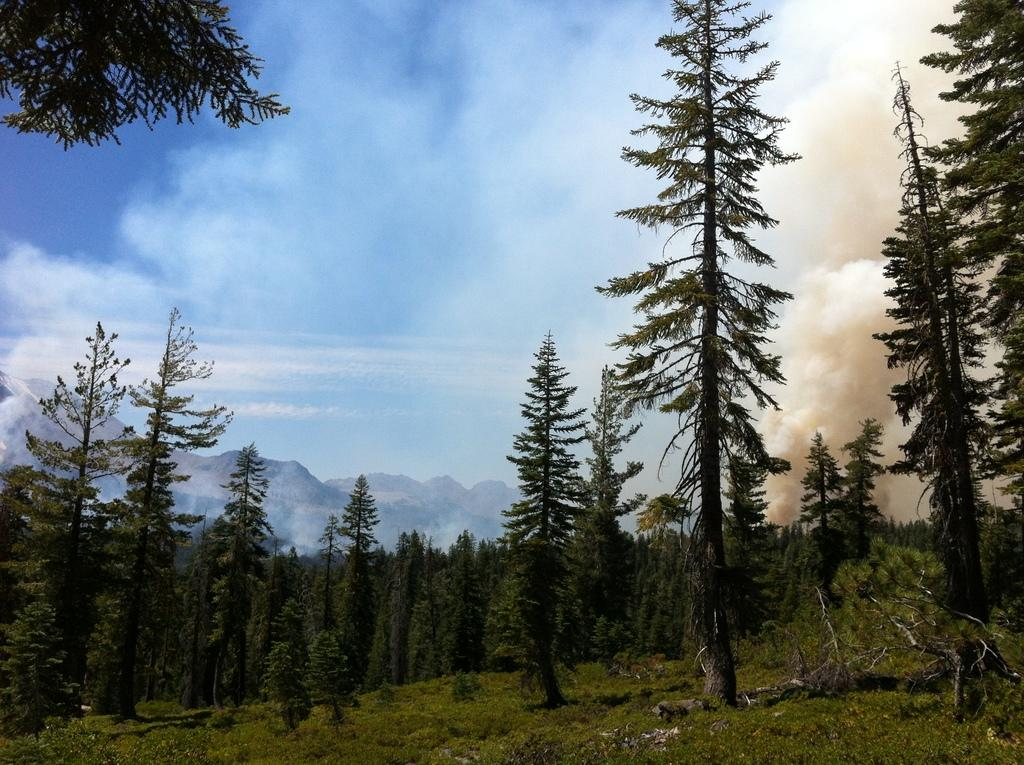What type of natural formation can be seen in the image? There is a group of trees in the image. What other natural features are visible in the background of the image? There is a group of mountains in the background of the image. What part of the sky is visible in the image? The sky is visible in the background of the image. What is the white substance present in the background of the image? White smoke is present in the background of the image. Where is the sink located in the image? There is no sink present in the image. What type of appliance can be seen on the edge of the trees? There are no appliances present in the image, and the trees do not have an edge. 